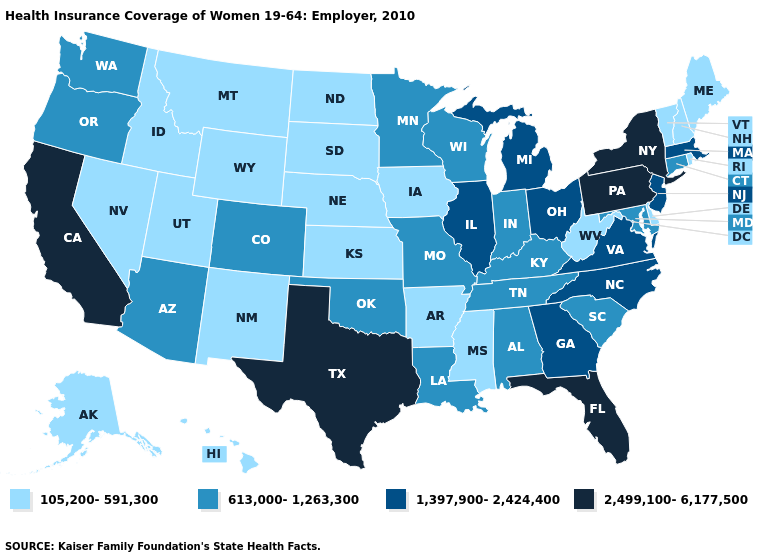Does Utah have the highest value in the West?
Concise answer only. No. Name the states that have a value in the range 105,200-591,300?
Short answer required. Alaska, Arkansas, Delaware, Hawaii, Idaho, Iowa, Kansas, Maine, Mississippi, Montana, Nebraska, Nevada, New Hampshire, New Mexico, North Dakota, Rhode Island, South Dakota, Utah, Vermont, West Virginia, Wyoming. Name the states that have a value in the range 105,200-591,300?
Keep it brief. Alaska, Arkansas, Delaware, Hawaii, Idaho, Iowa, Kansas, Maine, Mississippi, Montana, Nebraska, Nevada, New Hampshire, New Mexico, North Dakota, Rhode Island, South Dakota, Utah, Vermont, West Virginia, Wyoming. Which states have the highest value in the USA?
Concise answer only. California, Florida, New York, Pennsylvania, Texas. What is the highest value in the MidWest ?
Short answer required. 1,397,900-2,424,400. Name the states that have a value in the range 613,000-1,263,300?
Give a very brief answer. Alabama, Arizona, Colorado, Connecticut, Indiana, Kentucky, Louisiana, Maryland, Minnesota, Missouri, Oklahoma, Oregon, South Carolina, Tennessee, Washington, Wisconsin. What is the value of Alaska?
Write a very short answer. 105,200-591,300. Is the legend a continuous bar?
Keep it brief. No. Does Kansas have the lowest value in the MidWest?
Write a very short answer. Yes. Name the states that have a value in the range 105,200-591,300?
Write a very short answer. Alaska, Arkansas, Delaware, Hawaii, Idaho, Iowa, Kansas, Maine, Mississippi, Montana, Nebraska, Nevada, New Hampshire, New Mexico, North Dakota, Rhode Island, South Dakota, Utah, Vermont, West Virginia, Wyoming. Does Indiana have the lowest value in the MidWest?
Concise answer only. No. Name the states that have a value in the range 105,200-591,300?
Quick response, please. Alaska, Arkansas, Delaware, Hawaii, Idaho, Iowa, Kansas, Maine, Mississippi, Montana, Nebraska, Nevada, New Hampshire, New Mexico, North Dakota, Rhode Island, South Dakota, Utah, Vermont, West Virginia, Wyoming. What is the value of Alabama?
Short answer required. 613,000-1,263,300. Name the states that have a value in the range 613,000-1,263,300?
Concise answer only. Alabama, Arizona, Colorado, Connecticut, Indiana, Kentucky, Louisiana, Maryland, Minnesota, Missouri, Oklahoma, Oregon, South Carolina, Tennessee, Washington, Wisconsin. What is the value of Rhode Island?
Keep it brief. 105,200-591,300. 